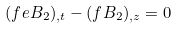<formula> <loc_0><loc_0><loc_500><loc_500>( f e B _ { 2 } ) _ { , t } - ( f B _ { 2 } ) _ { , z } = 0</formula> 